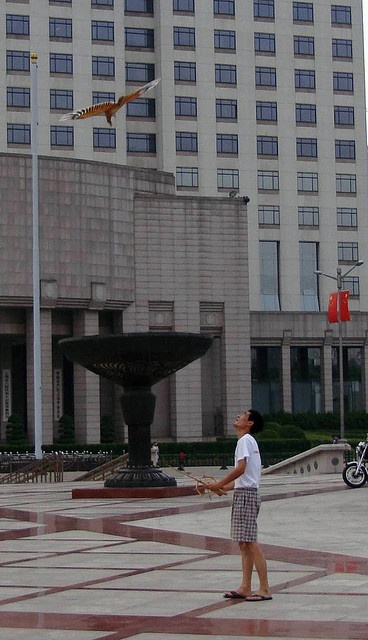Describe the objects in this image and their specific colors. I can see people in gray, darkgray, maroon, and black tones, kite in gray, maroon, and darkgray tones, motorcycle in gray, black, darkgray, and lightgray tones, people in gray and black tones, and people in black, maroon, and gray tones in this image. 